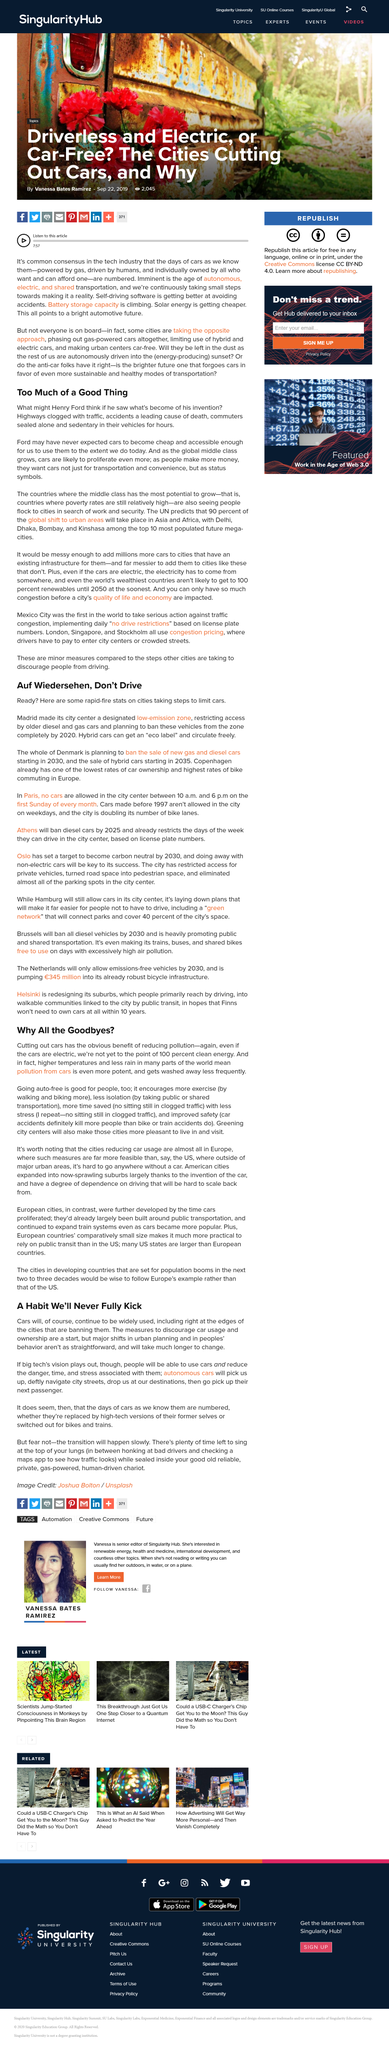Mention a couple of crucial points in this snapshot. Cities are implementing restrictions on the use of cars. Autonomous cars will perform a range of tasks, including picking up passengers, navigating streets, and dropping them off at their destinations, before selecting their next passenger. Henry Ford is credited with inventing the automobile, more commonly known as the car. Denmark will prohibit the purchase of new gasoline and diesel-powered vehicles by the year 2030. Cars are a leading cause of death and often perceived as status symbols. 